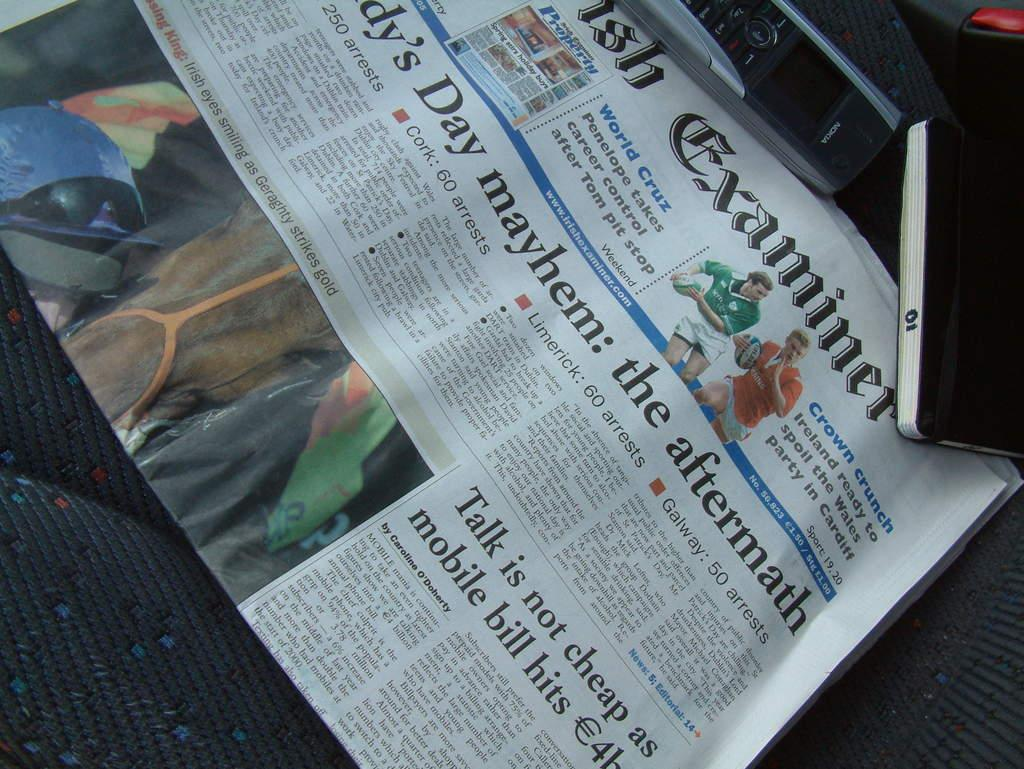<image>
Present a compact description of the photo's key features. Newspaper on the aftermath and talk is not cheap as mobile bill hits. 